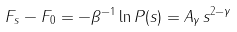Convert formula to latex. <formula><loc_0><loc_0><loc_500><loc_500>F _ { s } - F _ { 0 } = - \beta ^ { - 1 } \ln P ( s ) = A _ { \gamma } \, s ^ { 2 - \gamma }</formula> 